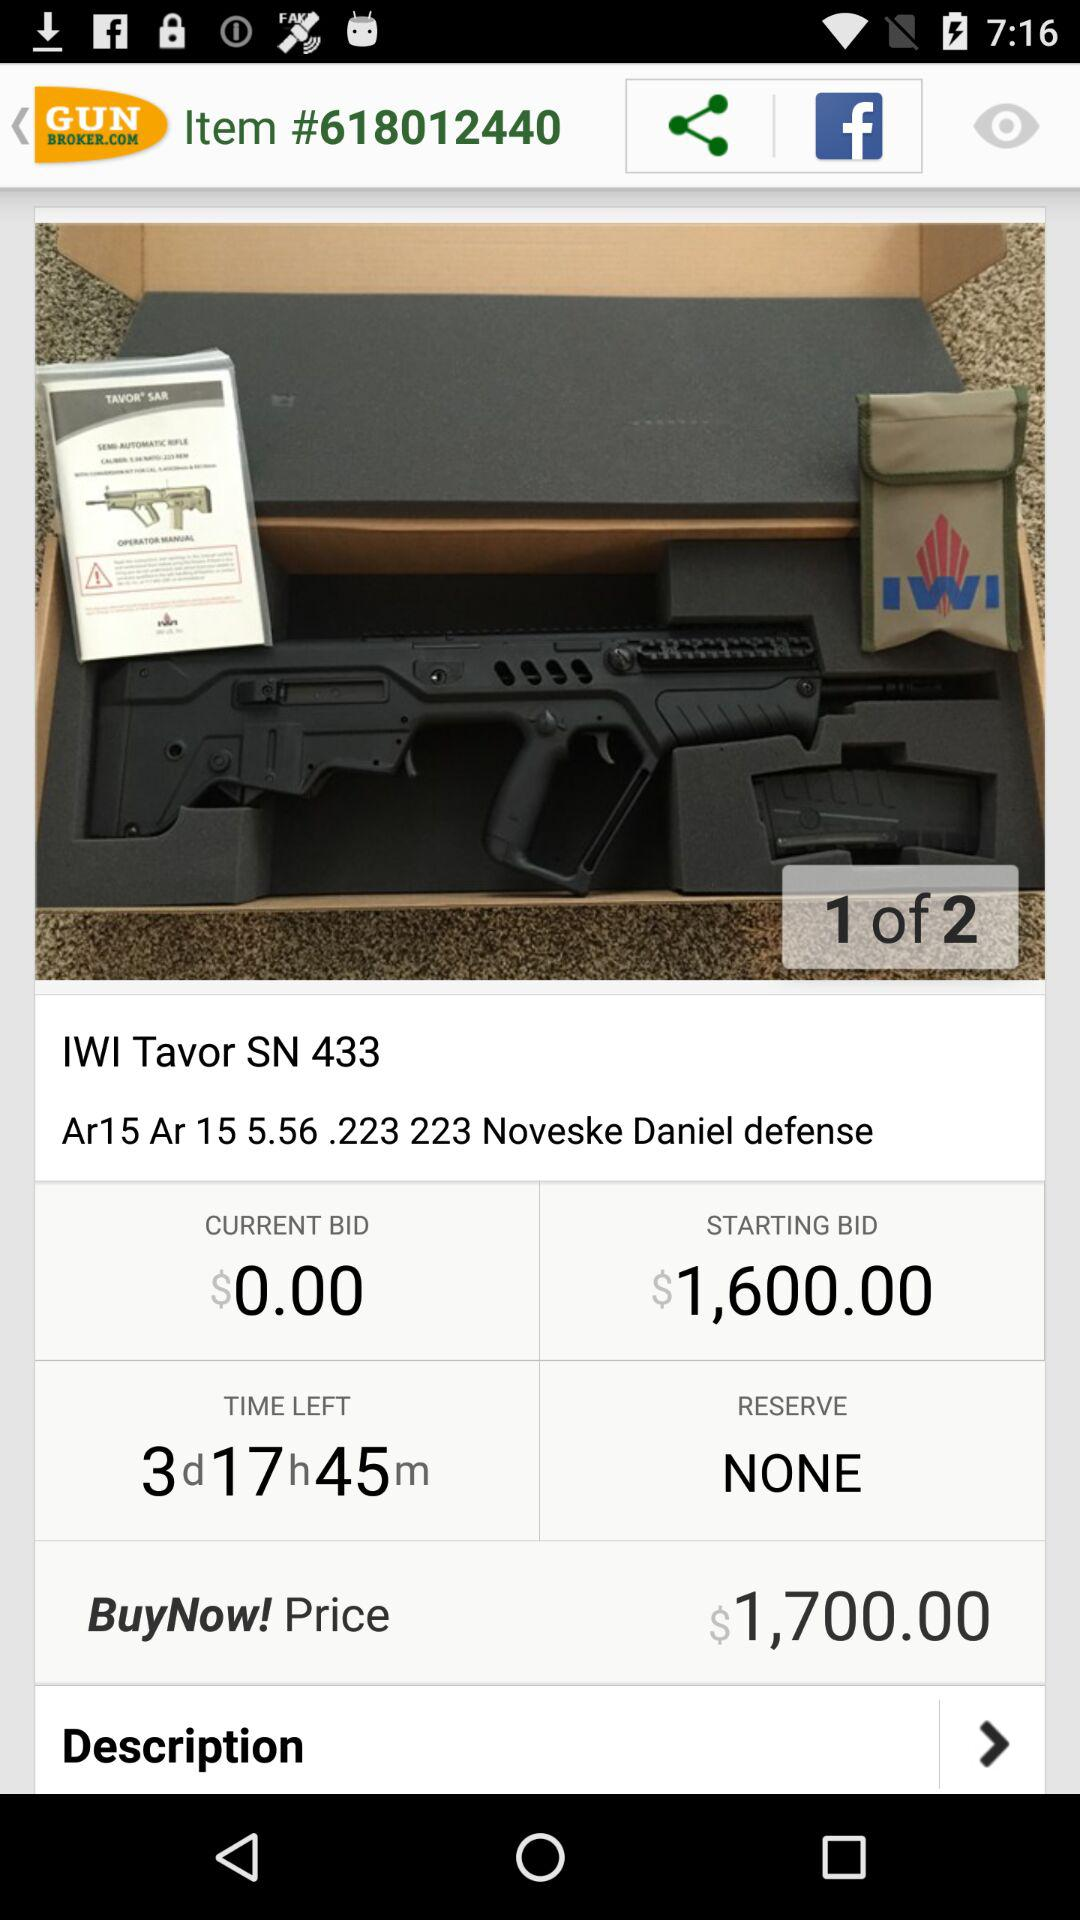Is there any reserve? There is no reserve. 